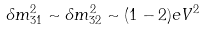Convert formula to latex. <formula><loc_0><loc_0><loc_500><loc_500>\delta m ^ { 2 } _ { 3 1 } \sim \delta m ^ { 2 } _ { 3 2 } \sim ( 1 - 2 ) e V ^ { 2 }</formula> 